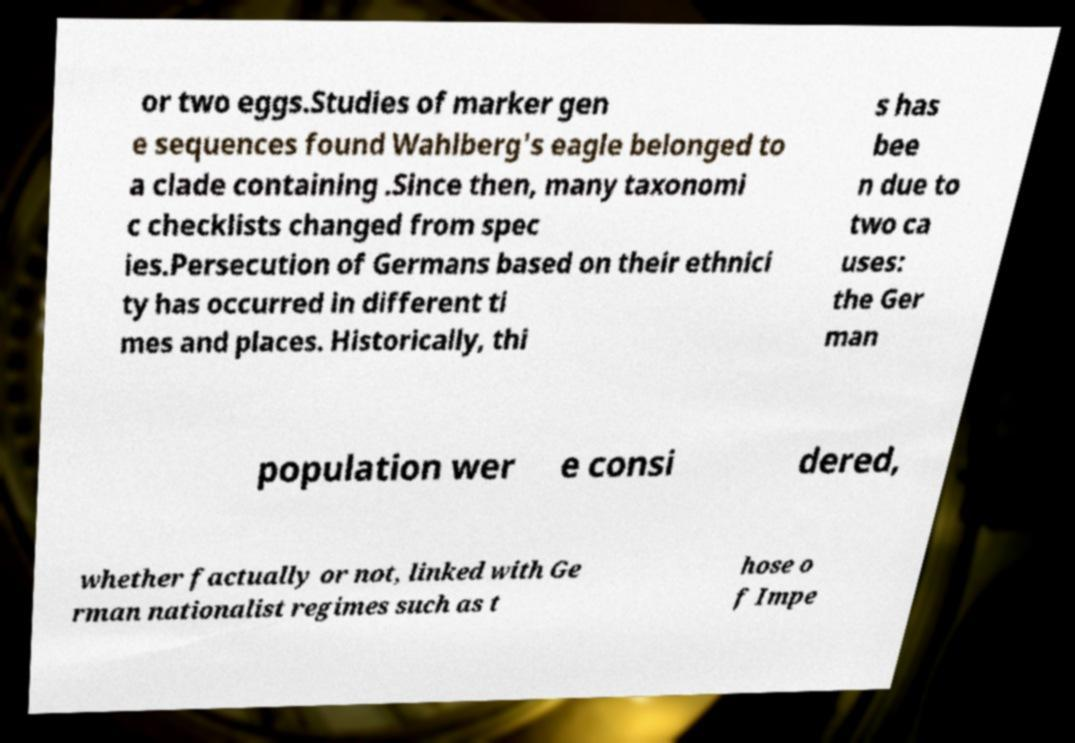I need the written content from this picture converted into text. Can you do that? or two eggs.Studies of marker gen e sequences found Wahlberg's eagle belonged to a clade containing .Since then, many taxonomi c checklists changed from spec ies.Persecution of Germans based on their ethnici ty has occurred in different ti mes and places. Historically, thi s has bee n due to two ca uses: the Ger man population wer e consi dered, whether factually or not, linked with Ge rman nationalist regimes such as t hose o f Impe 